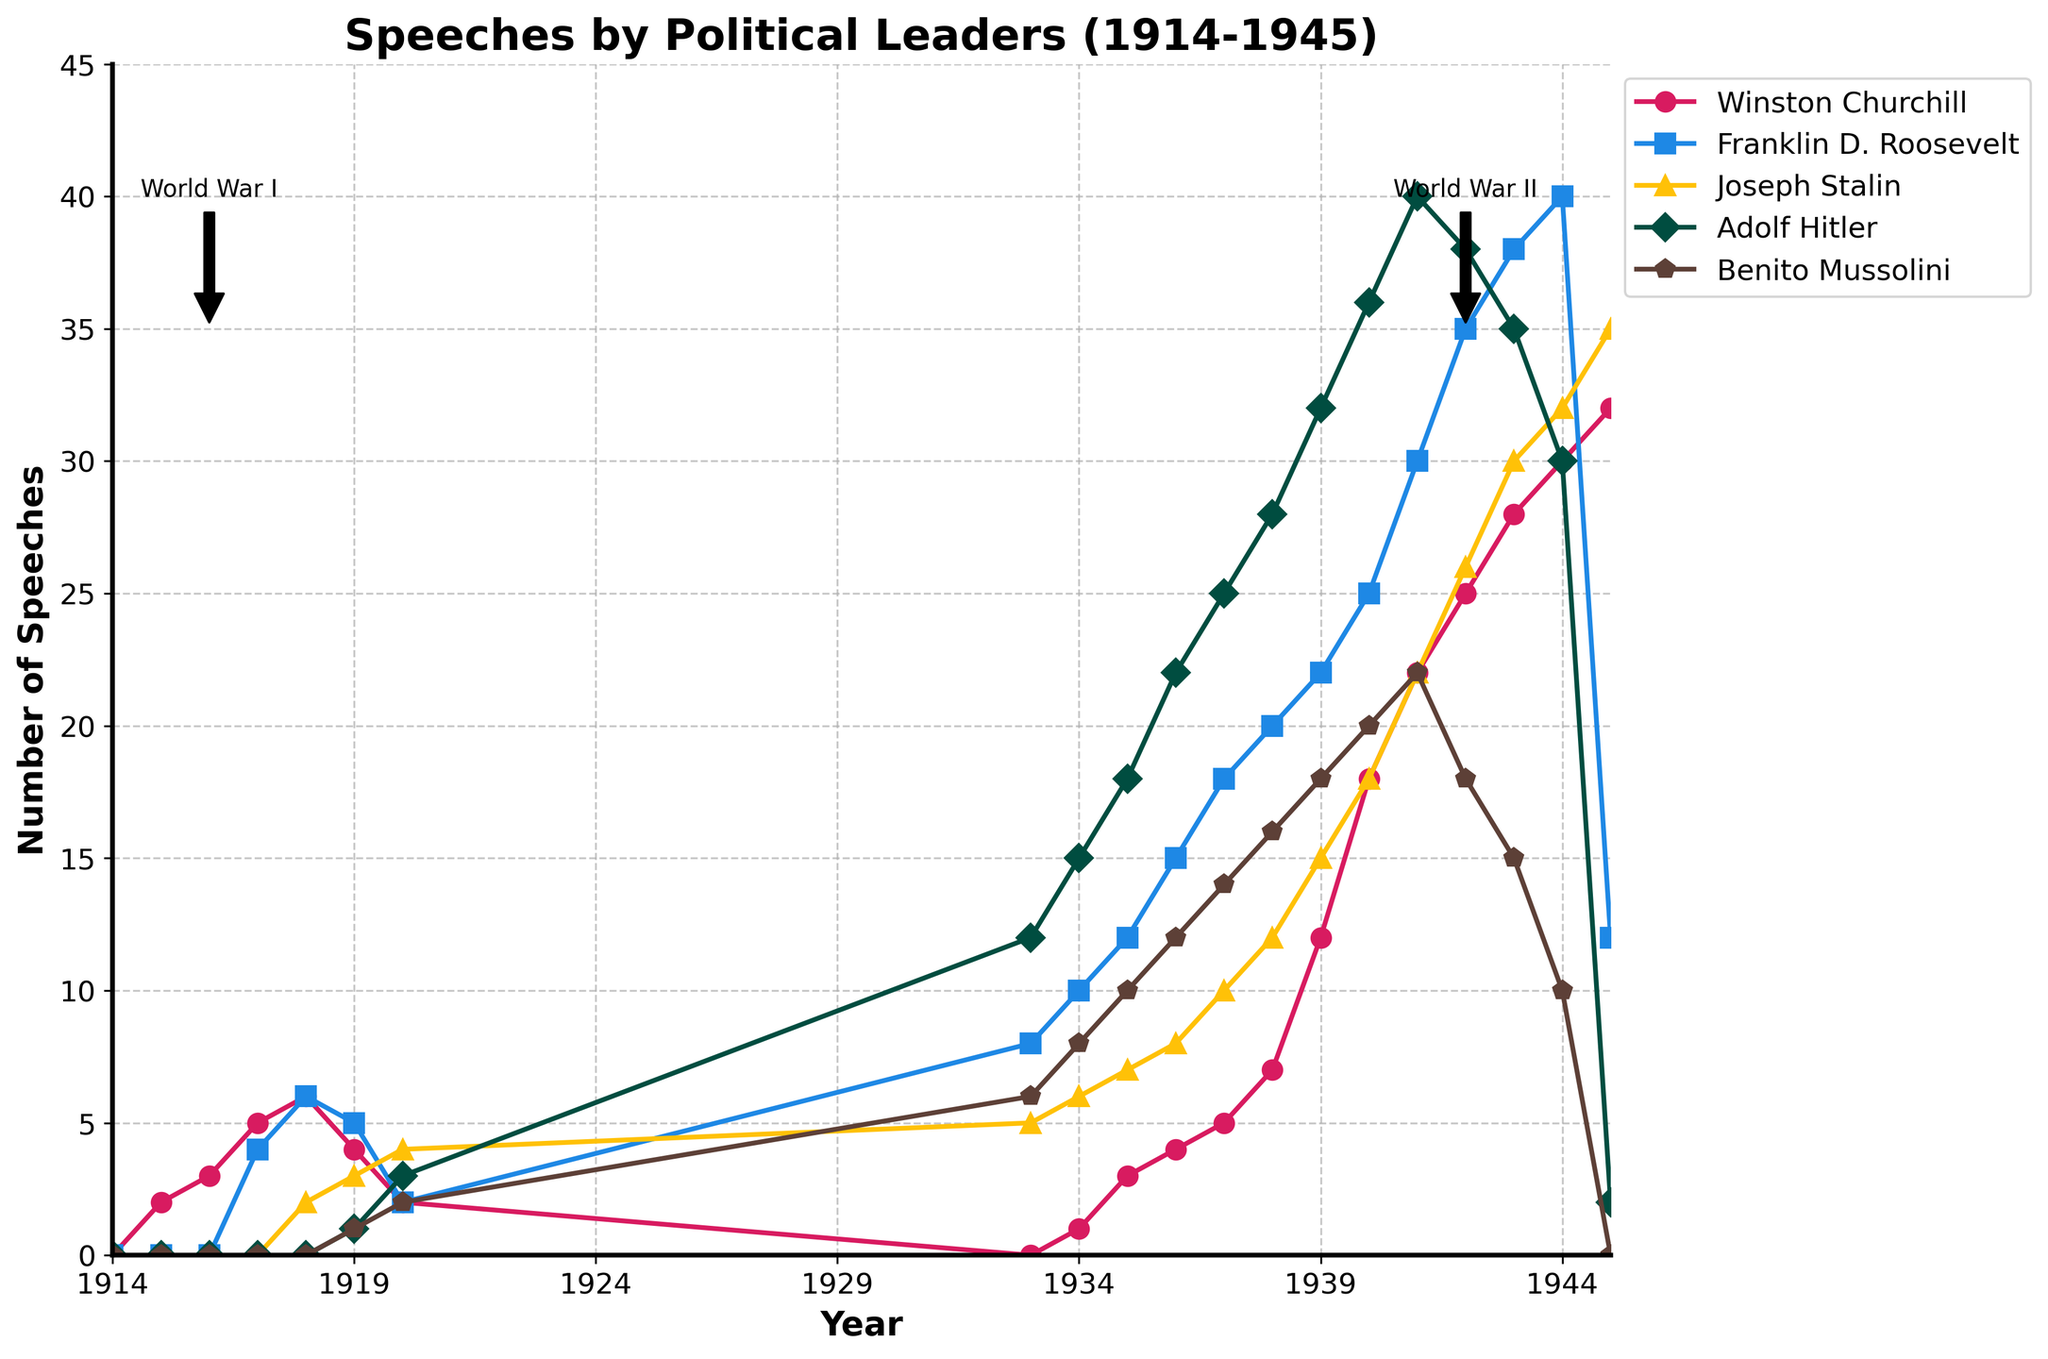Which year did Winston Churchill give the most speeches? To answer this, look at the line for Winston Churchill and find the highest point, which occurs in the year 1945.
Answer: 1945 Who gave more speeches in 1939, Adolf Hitler or Franklin D. Roosevelt? Check the values for Adolf Hitler and Franklin D. Roosevelt in 1939. Adolf Hitler gave 32 speeches, while Franklin D. Roosevelt gave 22 speeches.
Answer: Adolf Hitler How many total speeches did Joseph Stalin give during World War II (1939-1945)? Sum the values for Joseph Stalin from 1939 to 1945: 15 (1939) + 18 (1940) + 22 (1941) + 26 (1942) + 30 (1943) + 32 (1944) + 35 (1945) = 178.
Answer: 178 Which leader had the highest increase in the number of speeches between 1939 and 1940? Calculate the difference between speeches in 1940 and 1939 for each leader: Churchill (18-12=6), Roosevelt (25-22=3), Stalin (18-15=3), Hitler (36-32=4), Mussolini (20-18=2). Winston Churchill had the highest increase.
Answer: Winston Churchill How many more speeches did Winston Churchill give in 1944 compared to Benito Mussolini? Find the difference between the speeches of Winston Churchill and Benito Mussolini in 1944: 30 (Churchill) - 10 (Mussolini) = 20.
Answer: 20 In which year did Franklin D. Roosevelt give the least number of speeches during World War II? Look at the values for Roosevelt from 1939 to 1945 and find the smallest number, which is 12 in the year 1945.
Answer: 1945 Which leader ceased giving speeches after 1944? Look at the number of speeches given by each leader in 1944 and notice that Benito Mussolini's count drops to 0 in 1945.
Answer: Benito Mussolini Between 1937 and 1938, whose number of speeches increased the most? Calculate the difference between speeches in 1938 and 1937 for each leader: Churchill (7-5=2), Roosevelt (20-18=2), Stalin (12-10=2), Hitler (28-25=3), Mussolini (16-14=2). Adolf Hitler had the highest increase.
Answer: Adolf Hitler How many total speeches were given by all leaders in 1918? Sum the values for all leaders in 1918: 6 (Churchill) + 6 (Roosevelt) + 2 (Stalin) + 0 (Hitler) + 0 (Mussolini) = 14.
Answer: 14 